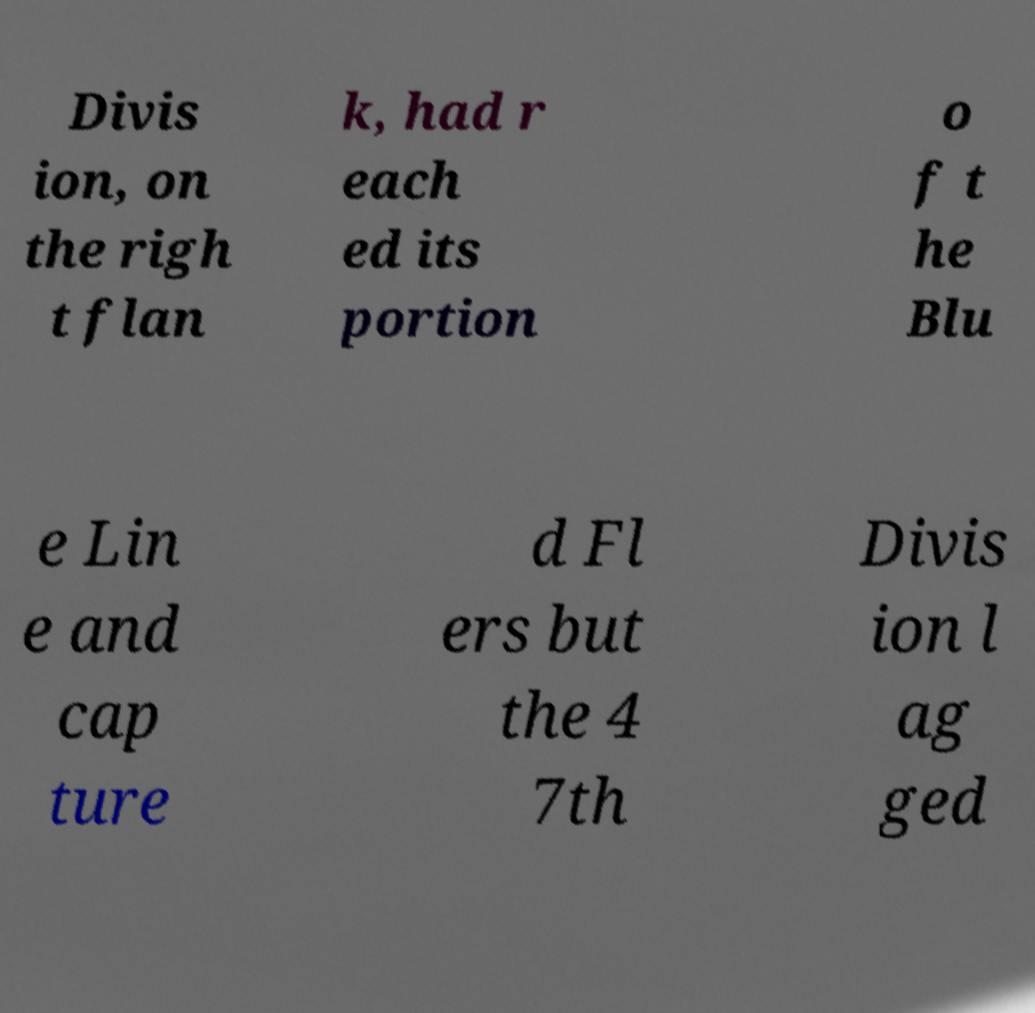Could you assist in decoding the text presented in this image and type it out clearly? Divis ion, on the righ t flan k, had r each ed its portion o f t he Blu e Lin e and cap ture d Fl ers but the 4 7th Divis ion l ag ged 